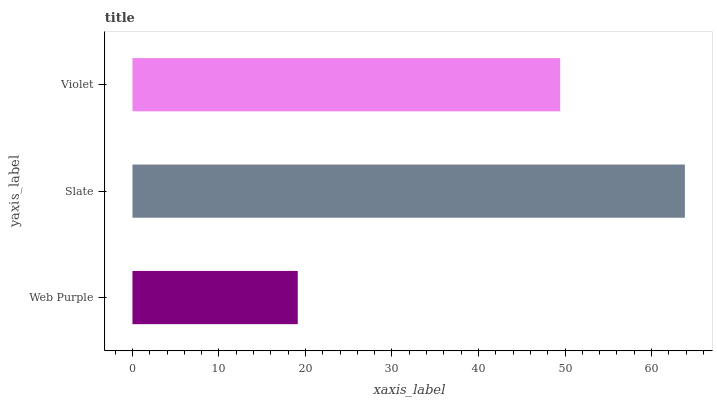Is Web Purple the minimum?
Answer yes or no. Yes. Is Slate the maximum?
Answer yes or no. Yes. Is Violet the minimum?
Answer yes or no. No. Is Violet the maximum?
Answer yes or no. No. Is Slate greater than Violet?
Answer yes or no. Yes. Is Violet less than Slate?
Answer yes or no. Yes. Is Violet greater than Slate?
Answer yes or no. No. Is Slate less than Violet?
Answer yes or no. No. Is Violet the high median?
Answer yes or no. Yes. Is Violet the low median?
Answer yes or no. Yes. Is Slate the high median?
Answer yes or no. No. Is Slate the low median?
Answer yes or no. No. 